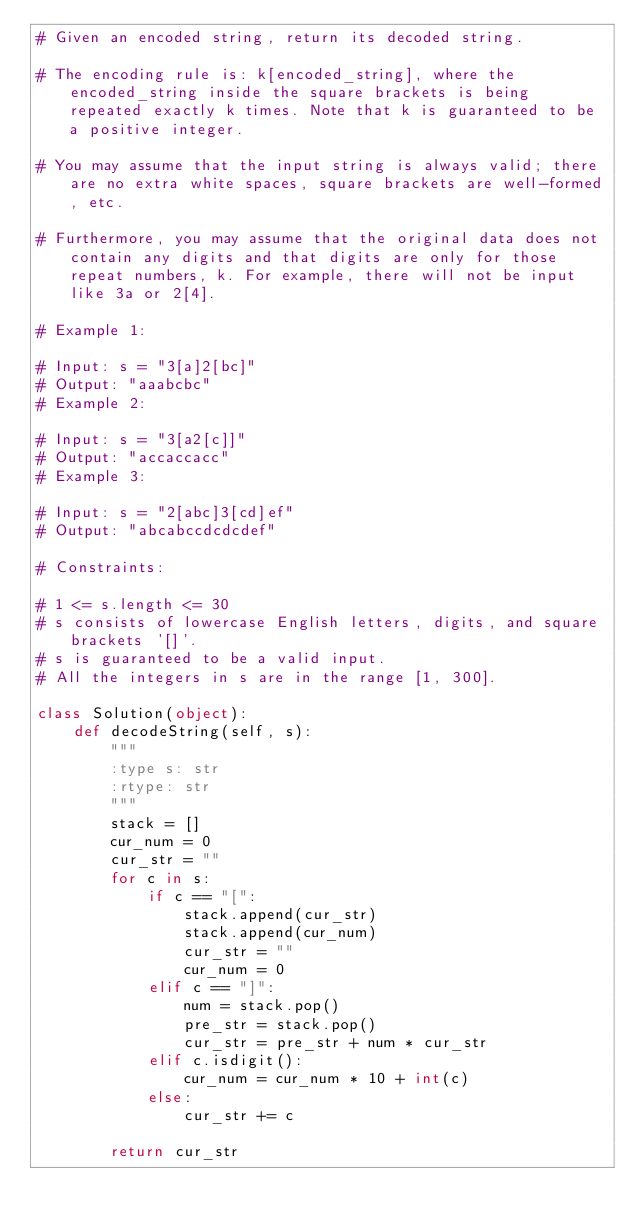Convert code to text. <code><loc_0><loc_0><loc_500><loc_500><_Python_># Given an encoded string, return its decoded string.

# The encoding rule is: k[encoded_string], where the encoded_string inside the square brackets is being repeated exactly k times. Note that k is guaranteed to be a positive integer.

# You may assume that the input string is always valid; there are no extra white spaces, square brackets are well-formed, etc.

# Furthermore, you may assume that the original data does not contain any digits and that digits are only for those repeat numbers, k. For example, there will not be input like 3a or 2[4].

# Example 1:

# Input: s = "3[a]2[bc]"
# Output: "aaabcbc"
# Example 2:

# Input: s = "3[a2[c]]"
# Output: "accaccacc"
# Example 3:

# Input: s = "2[abc]3[cd]ef"
# Output: "abcabccdcdcdef"
 
# Constraints:

# 1 <= s.length <= 30
# s consists of lowercase English letters, digits, and square brackets '[]'.
# s is guaranteed to be a valid input.
# All the integers in s are in the range [1, 300].

class Solution(object):
    def decodeString(self, s):
        """
        :type s: str
        :rtype: str
        """
        stack = []
        cur_num = 0
        cur_str = ""
        for c in s:
            if c == "[":
                stack.append(cur_str)
                stack.append(cur_num)
                cur_str = ""
                cur_num = 0
            elif c == "]":
                num = stack.pop()
                pre_str = stack.pop()
                cur_str = pre_str + num * cur_str
            elif c.isdigit():
                cur_num = cur_num * 10 + int(c)
            else:
                cur_str += c
                
        return cur_str</code> 